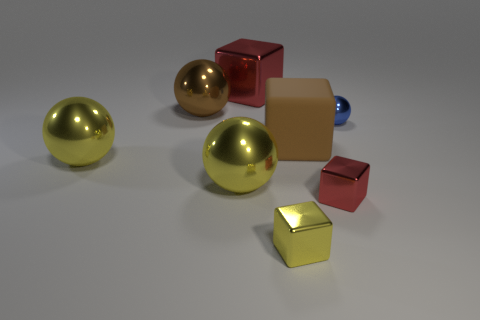Are there more big shiny blocks than yellow metal balls?
Offer a very short reply. No. What is the size of the metallic thing that is the same color as the rubber object?
Give a very brief answer. Large. What size is the block that is both behind the small red metallic cube and right of the big red block?
Provide a succinct answer. Large. What material is the big brown object that is left of the red metal cube that is behind the red shiny thing in front of the tiny blue ball?
Your answer should be very brief. Metal. What material is the other large thing that is the same color as the matte thing?
Provide a short and direct response. Metal. There is a cube that is behind the large brown block; is its color the same as the tiny metal cube that is to the right of the yellow cube?
Your response must be concise. Yes. What shape is the small thing that is in front of the red shiny block to the right of the large brown object on the right side of the small yellow block?
Your response must be concise. Cube. There is a big shiny thing that is both to the right of the brown ball and in front of the big red block; what is its shape?
Offer a very short reply. Sphere. There is a shiny thing that is behind the metallic sphere behind the blue object; how many large spheres are in front of it?
Your response must be concise. 3. What is the size of the yellow shiny thing that is the same shape as the small red metallic object?
Your answer should be compact. Small. 